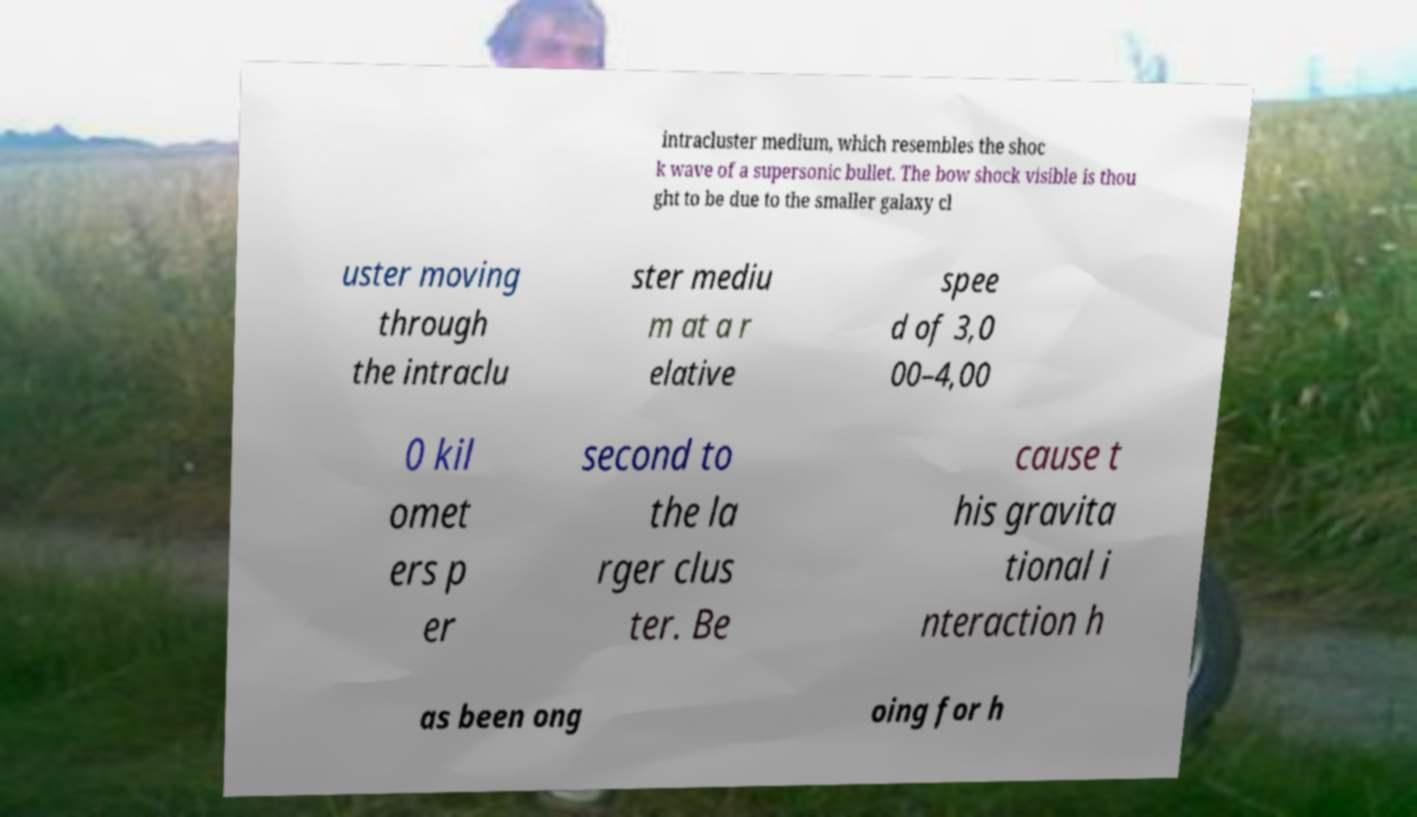For documentation purposes, I need the text within this image transcribed. Could you provide that? intracluster medium, which resembles the shoc k wave of a supersonic bullet. The bow shock visible is thou ght to be due to the smaller galaxy cl uster moving through the intraclu ster mediu m at a r elative spee d of 3,0 00–4,00 0 kil omet ers p er second to the la rger clus ter. Be cause t his gravita tional i nteraction h as been ong oing for h 